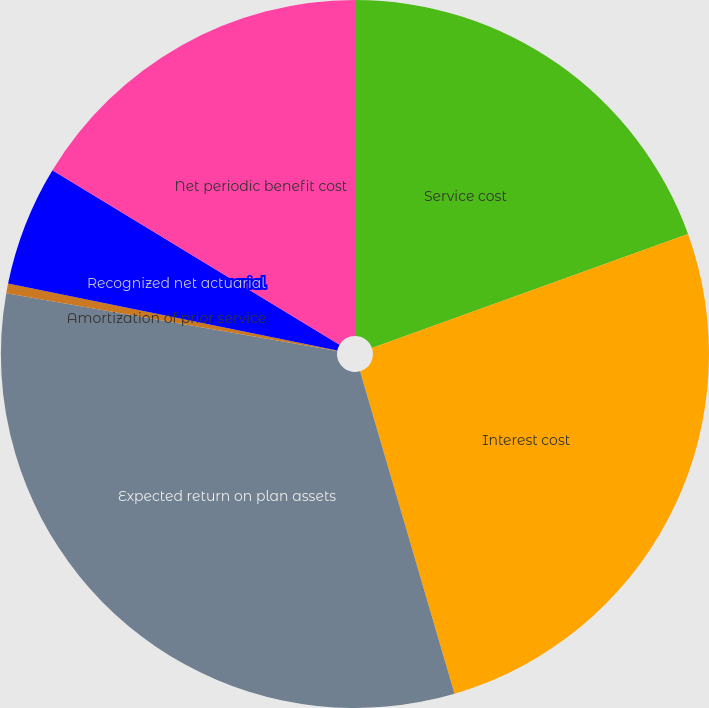<chart> <loc_0><loc_0><loc_500><loc_500><pie_chart><fcel>Service cost<fcel>Interest cost<fcel>Expected return on plan assets<fcel>Amortization of prior service<fcel>Recognized net actuarial<fcel>Net periodic benefit cost<nl><fcel>19.49%<fcel>25.97%<fcel>32.28%<fcel>0.44%<fcel>5.5%<fcel>16.31%<nl></chart> 